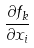<formula> <loc_0><loc_0><loc_500><loc_500>\frac { \partial f _ { k } } { \partial x _ { i } }</formula> 